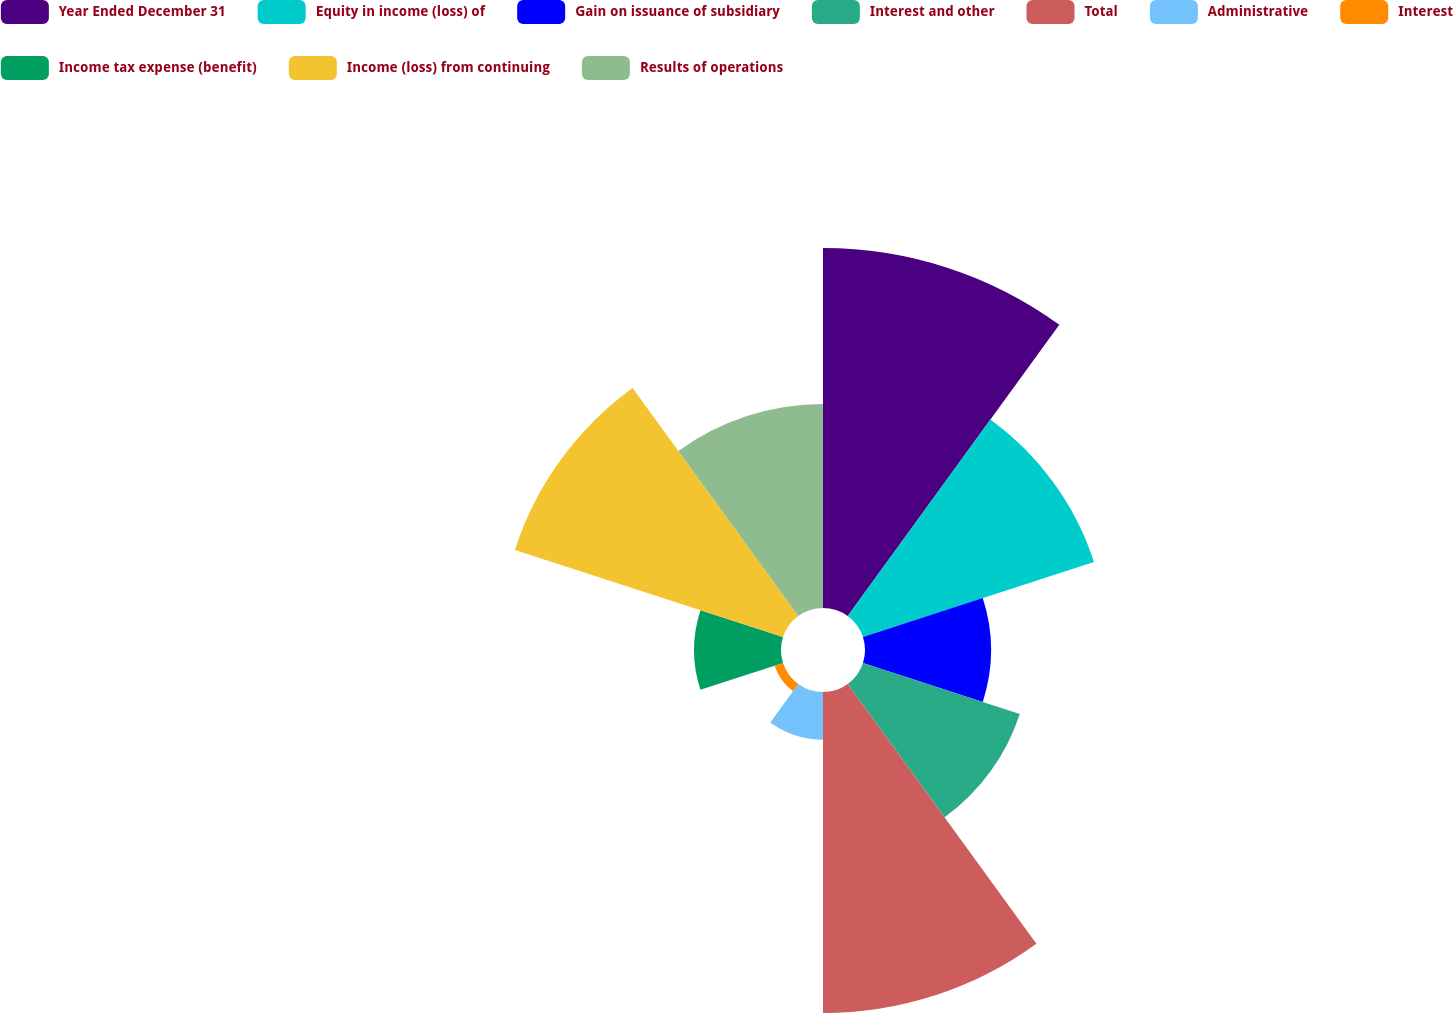Convert chart to OTSL. <chart><loc_0><loc_0><loc_500><loc_500><pie_chart><fcel>Year Ended December 31<fcel>Equity in income (loss) of<fcel>Gain on issuance of subsidiary<fcel>Interest and other<fcel>Total<fcel>Administrative<fcel>Interest<fcel>Income tax expense (benefit)<fcel>Income (loss) from continuing<fcel>Results of operations<nl><fcel>19.52%<fcel>13.17%<fcel>6.83%<fcel>8.94%<fcel>17.41%<fcel>2.59%<fcel>0.48%<fcel>4.71%<fcel>15.29%<fcel>11.06%<nl></chart> 